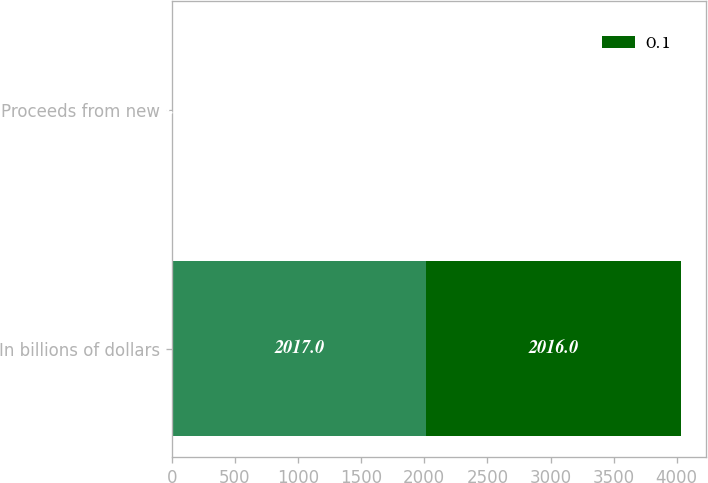Convert chart to OTSL. <chart><loc_0><loc_0><loc_500><loc_500><stacked_bar_chart><ecel><fcel>In billions of dollars<fcel>Proceeds from new<nl><fcel>nan<fcel>2017<fcel>3.5<nl><fcel>0.1<fcel>2016<fcel>5<nl></chart> 